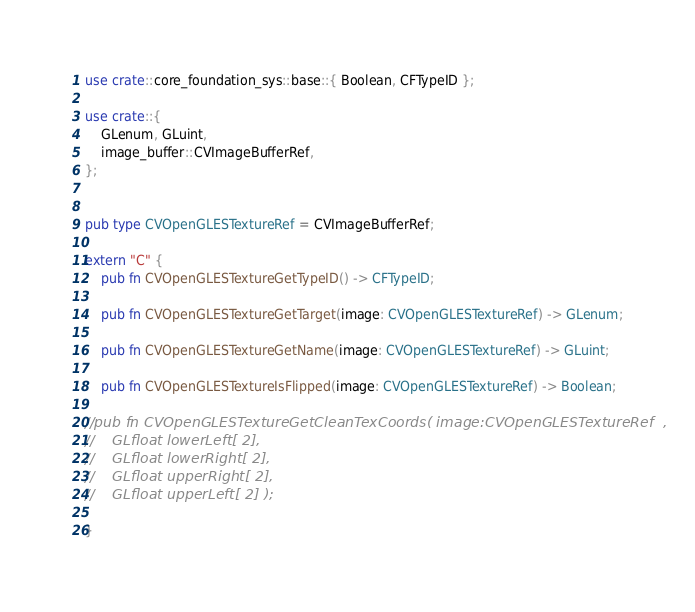<code> <loc_0><loc_0><loc_500><loc_500><_Rust_>use crate::core_foundation_sys::base::{ Boolean, CFTypeID };

use crate::{
    GLenum, GLuint,
    image_buffer::CVImageBufferRef,
};


pub type CVOpenGLESTextureRef = CVImageBufferRef;

extern "C" {
    pub fn CVOpenGLESTextureGetTypeID() -> CFTypeID;

    pub fn CVOpenGLESTextureGetTarget(image: CVOpenGLESTextureRef) -> GLenum;

    pub fn CVOpenGLESTextureGetName(image: CVOpenGLESTextureRef) -> GLuint;

    pub fn CVOpenGLESTextureIsFlipped(image: CVOpenGLESTextureRef) -> Boolean;

//pub fn CVOpenGLESTextureGetCleanTexCoords( image:CVOpenGLESTextureRef  ,
//    GLfloat lowerLeft[ 2],
//    GLfloat lowerRight[ 2],
//    GLfloat upperRight[ 2],
//    GLfloat upperLeft[ 2] );

}
</code> 